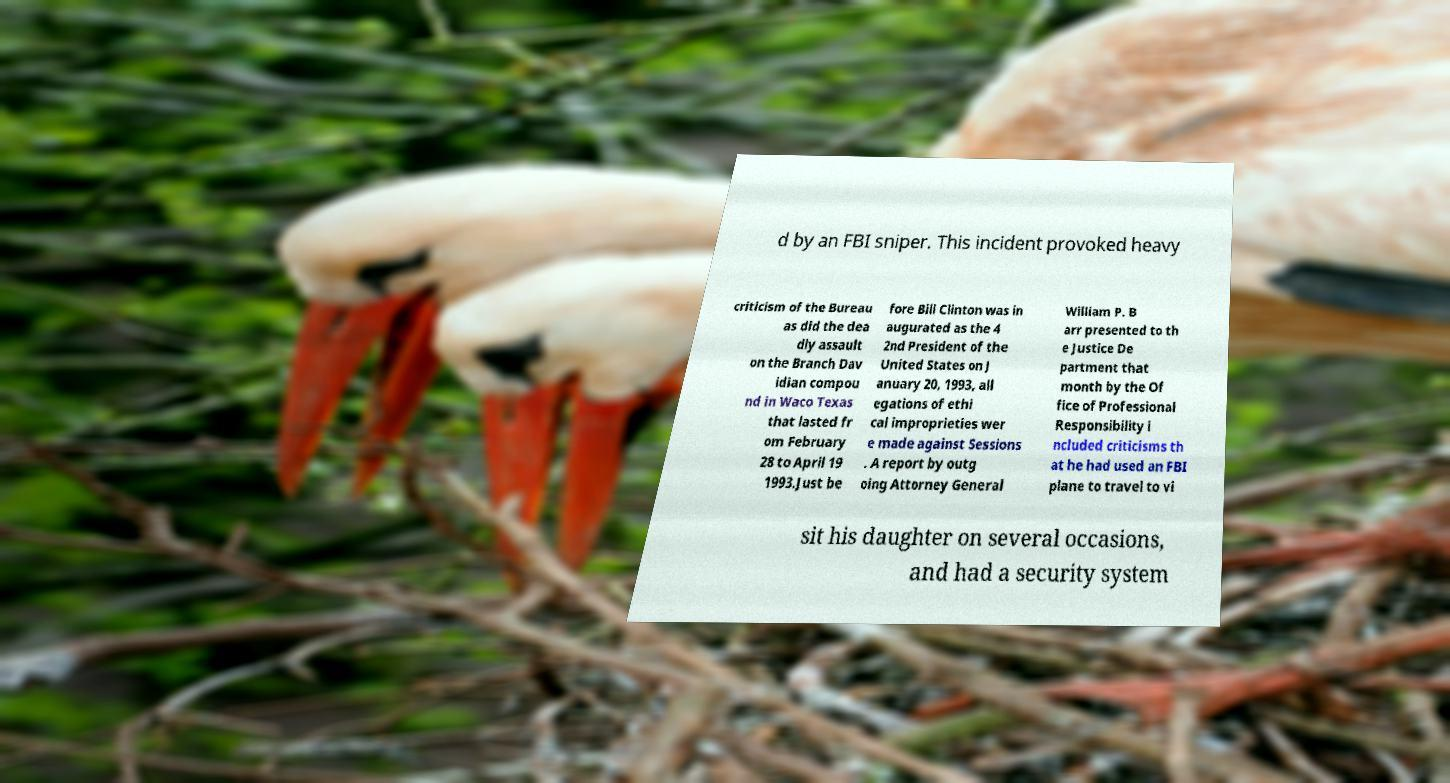Please read and relay the text visible in this image. What does it say? d by an FBI sniper. This incident provoked heavy criticism of the Bureau as did the dea dly assault on the Branch Dav idian compou nd in Waco Texas that lasted fr om February 28 to April 19 1993.Just be fore Bill Clinton was in augurated as the 4 2nd President of the United States on J anuary 20, 1993, all egations of ethi cal improprieties wer e made against Sessions . A report by outg oing Attorney General William P. B arr presented to th e Justice De partment that month by the Of fice of Professional Responsibility i ncluded criticisms th at he had used an FBI plane to travel to vi sit his daughter on several occasions, and had a security system 